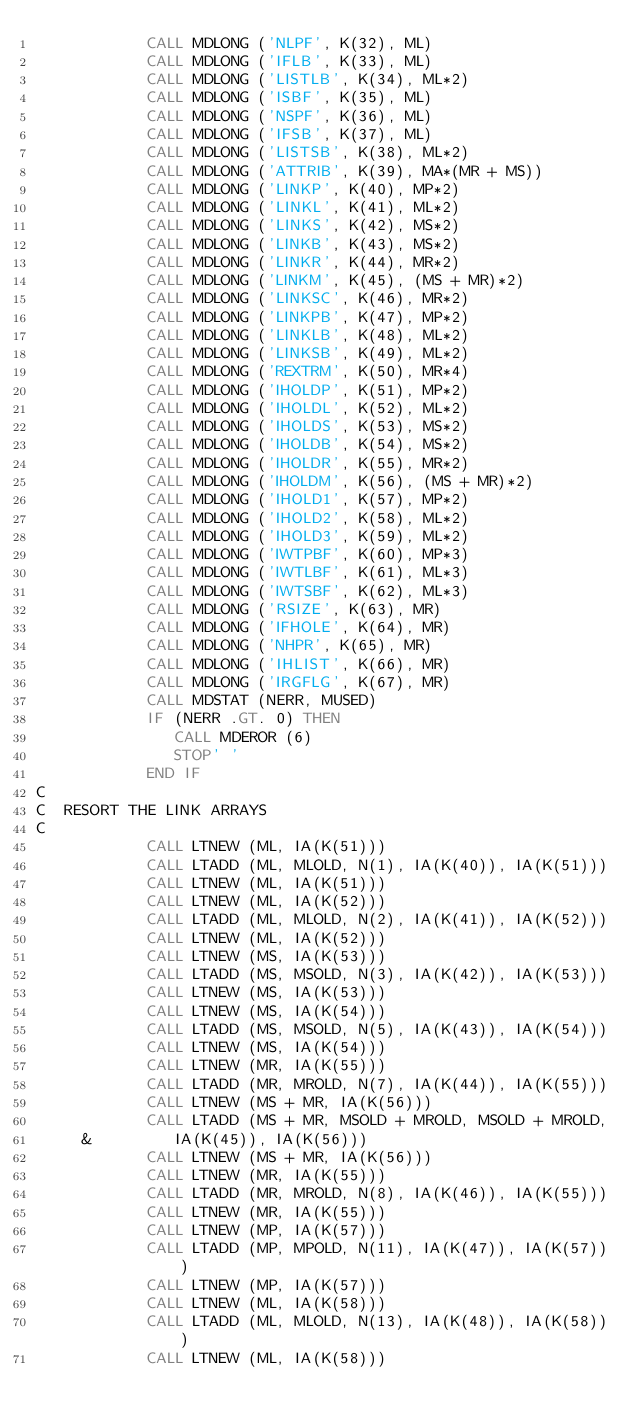<code> <loc_0><loc_0><loc_500><loc_500><_FORTRAN_>            CALL MDLONG ('NLPF', K(32), ML)
            CALL MDLONG ('IFLB', K(33), ML)
            CALL MDLONG ('LISTLB', K(34), ML*2)
            CALL MDLONG ('ISBF', K(35), ML)
            CALL MDLONG ('NSPF', K(36), ML)
            CALL MDLONG ('IFSB', K(37), ML)
            CALL MDLONG ('LISTSB', K(38), ML*2)
            CALL MDLONG ('ATTRIB', K(39), MA*(MR + MS))
            CALL MDLONG ('LINKP', K(40), MP*2)
            CALL MDLONG ('LINKL', K(41), ML*2)
            CALL MDLONG ('LINKS', K(42), MS*2)
            CALL MDLONG ('LINKB', K(43), MS*2)
            CALL MDLONG ('LINKR', K(44), MR*2)
            CALL MDLONG ('LINKM', K(45), (MS + MR)*2)
            CALL MDLONG ('LINKSC', K(46), MR*2)
            CALL MDLONG ('LINKPB', K(47), MP*2)
            CALL MDLONG ('LINKLB', K(48), ML*2)
            CALL MDLONG ('LINKSB', K(49), ML*2)
            CALL MDLONG ('REXTRM', K(50), MR*4)
            CALL MDLONG ('IHOLDP', K(51), MP*2)
            CALL MDLONG ('IHOLDL', K(52), ML*2)
            CALL MDLONG ('IHOLDS', K(53), MS*2)
            CALL MDLONG ('IHOLDB', K(54), MS*2)
            CALL MDLONG ('IHOLDR', K(55), MR*2)
            CALL MDLONG ('IHOLDM', K(56), (MS + MR)*2)
            CALL MDLONG ('IHOLD1', K(57), MP*2)
            CALL MDLONG ('IHOLD2', K(58), ML*2)
            CALL MDLONG ('IHOLD3', K(59), ML*2)
            CALL MDLONG ('IWTPBF', K(60), MP*3)
            CALL MDLONG ('IWTLBF', K(61), ML*3)
            CALL MDLONG ('IWTSBF', K(62), ML*3)
            CALL MDLONG ('RSIZE', K(63), MR)
            CALL MDLONG ('IFHOLE', K(64), MR)
            CALL MDLONG ('NHPR', K(65), MR)
            CALL MDLONG ('IHLIST', K(66), MR)
            CALL MDLONG ('IRGFLG', K(67), MR)
            CALL MDSTAT (NERR, MUSED)
            IF (NERR .GT. 0) THEN
               CALL MDEROR (6)
               STOP' '
            END IF
C
C  RESORT THE LINK ARRAYS
C
            CALL LTNEW (ML, IA(K(51)))
            CALL LTADD (ML, MLOLD, N(1), IA(K(40)), IA(K(51)))
            CALL LTNEW (ML, IA(K(51)))
            CALL LTNEW (ML, IA(K(52)))
            CALL LTADD (ML, MLOLD, N(2), IA(K(41)), IA(K(52)))
            CALL LTNEW (ML, IA(K(52)))
            CALL LTNEW (MS, IA(K(53)))
            CALL LTADD (MS, MSOLD, N(3), IA(K(42)), IA(K(53)))
            CALL LTNEW (MS, IA(K(53)))
            CALL LTNEW (MS, IA(K(54)))
            CALL LTADD (MS, MSOLD, N(5), IA(K(43)), IA(K(54)))
            CALL LTNEW (MS, IA(K(54)))
            CALL LTNEW (MR, IA(K(55)))
            CALL LTADD (MR, MROLD, N(7), IA(K(44)), IA(K(55)))
            CALL LTNEW (MS + MR, IA(K(56)))
            CALL LTADD (MS + MR, MSOLD + MROLD, MSOLD + MROLD,
     &         IA(K(45)), IA(K(56)))
            CALL LTNEW (MS + MR, IA(K(56)))
            CALL LTNEW (MR, IA(K(55)))
            CALL LTADD (MR, MROLD, N(8), IA(K(46)), IA(K(55)))
            CALL LTNEW (MR, IA(K(55)))
            CALL LTNEW (MP, IA(K(57)))
            CALL LTADD (MP, MPOLD, N(11), IA(K(47)), IA(K(57)))
            CALL LTNEW (MP, IA(K(57)))
            CALL LTNEW (ML, IA(K(58)))
            CALL LTADD (ML, MLOLD, N(13), IA(K(48)), IA(K(58)))
            CALL LTNEW (ML, IA(K(58)))</code> 